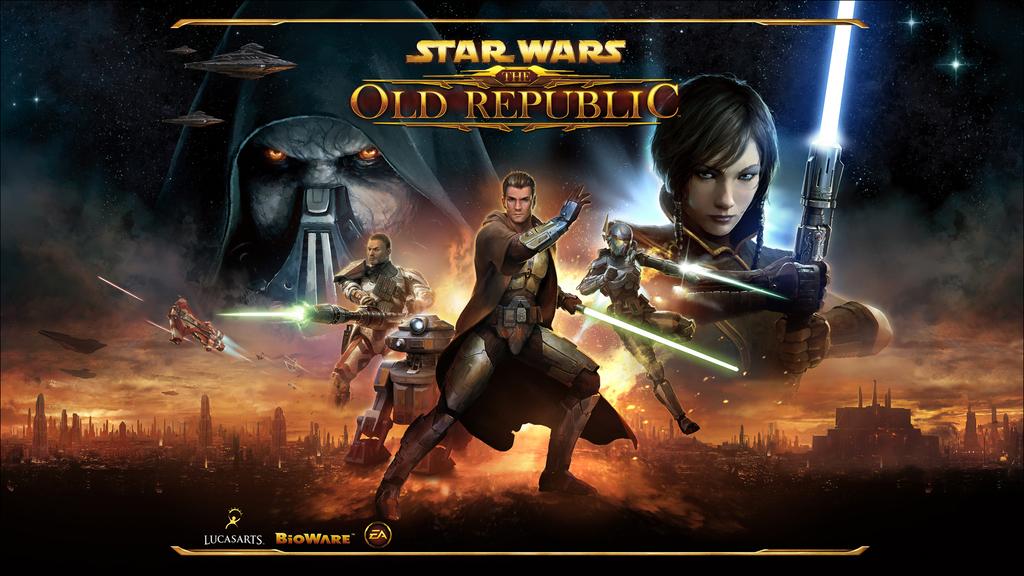Which company made the game?
Ensure brevity in your answer.  Bioware. 